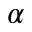Convert formula to latex. <formula><loc_0><loc_0><loc_500><loc_500>\alpha</formula> 